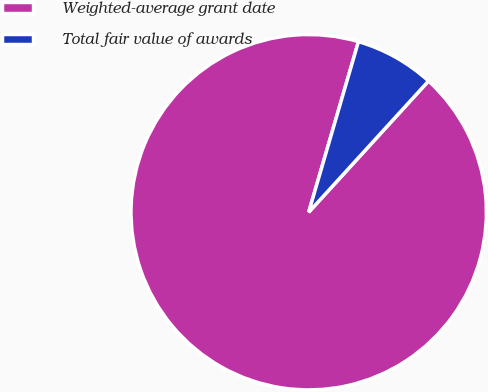Convert chart. <chart><loc_0><loc_0><loc_500><loc_500><pie_chart><fcel>Weighted-average grant date<fcel>Total fair value of awards<nl><fcel>92.74%<fcel>7.26%<nl></chart> 